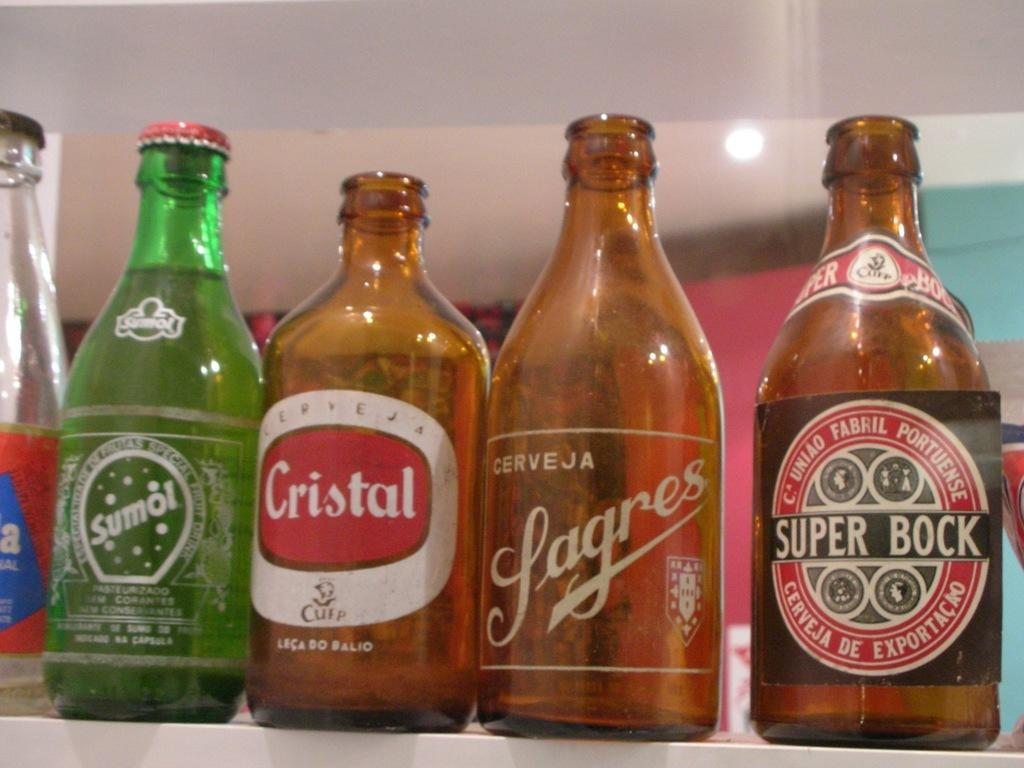<image>
Give a short and clear explanation of the subsequent image. Different bottles are lined up next to each other, the Sumol produt being the only full one. 